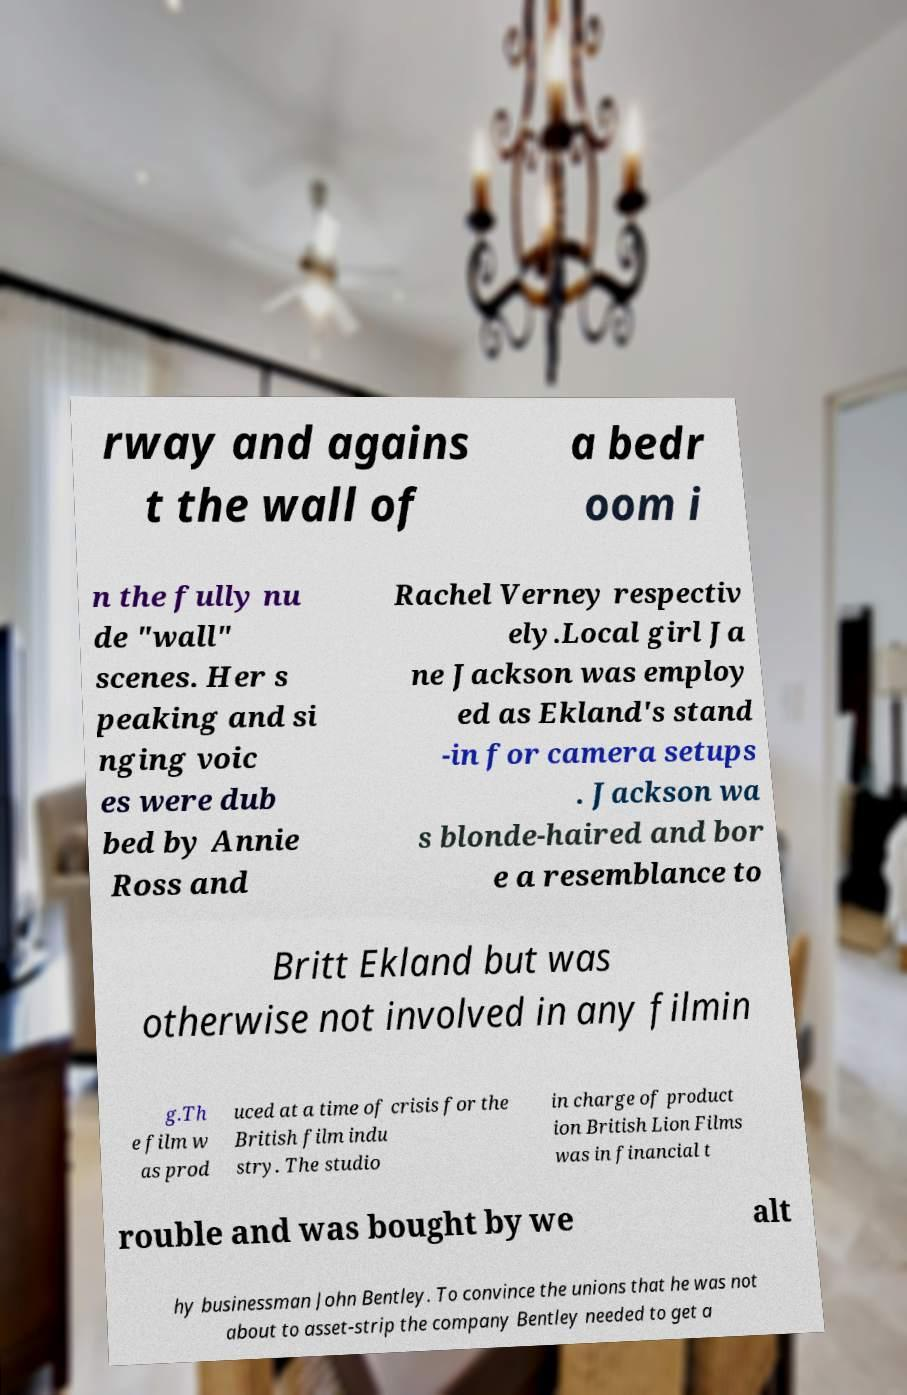Can you accurately transcribe the text from the provided image for me? rway and agains t the wall of a bedr oom i n the fully nu de "wall" scenes. Her s peaking and si nging voic es were dub bed by Annie Ross and Rachel Verney respectiv ely.Local girl Ja ne Jackson was employ ed as Ekland's stand -in for camera setups . Jackson wa s blonde-haired and bor e a resemblance to Britt Ekland but was otherwise not involved in any filmin g.Th e film w as prod uced at a time of crisis for the British film indu stry. The studio in charge of product ion British Lion Films was in financial t rouble and was bought by we alt hy businessman John Bentley. To convince the unions that he was not about to asset-strip the company Bentley needed to get a 